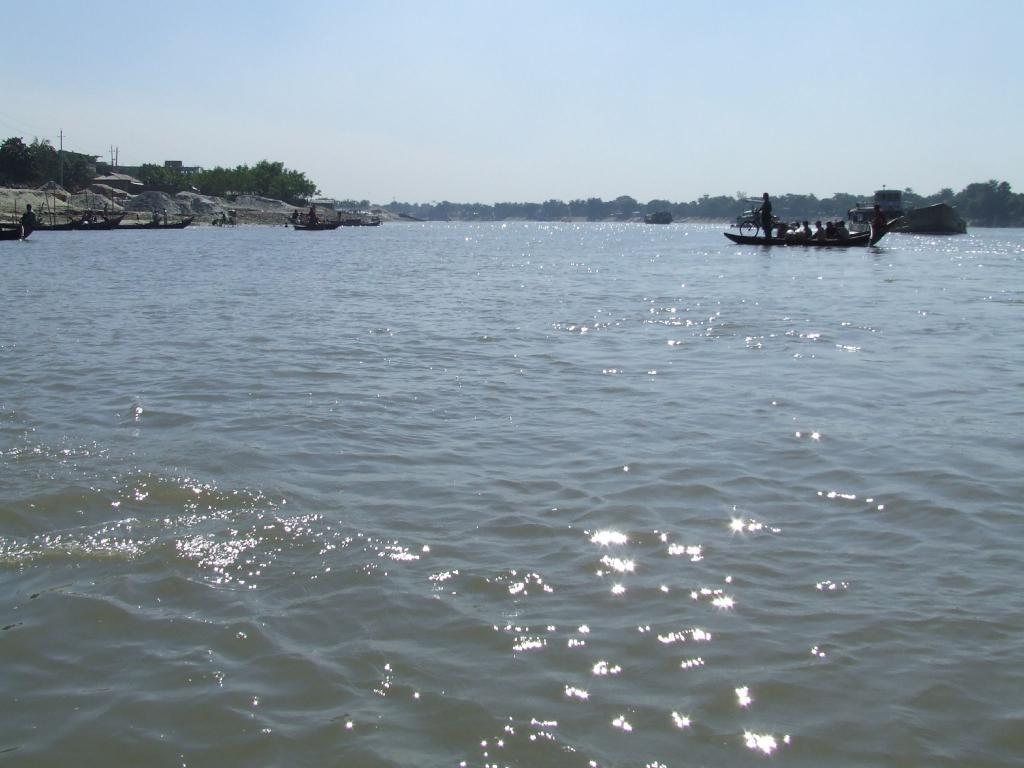What type of water body is present in the image? There is a river in the image. What are the people in the image doing? People are sailing boats in the river. What geographical features can be seen in the image? There are rock mountains in the image. What type of vegetation is present in the image? There are trees in the image. What is visible in the background of the image? The sky is visible in the background of the image. Can you tell me who won the argument between the grandfather and the cow in the image? There is no grandfather or cow present in the image, and therefore no argument can be observed. 